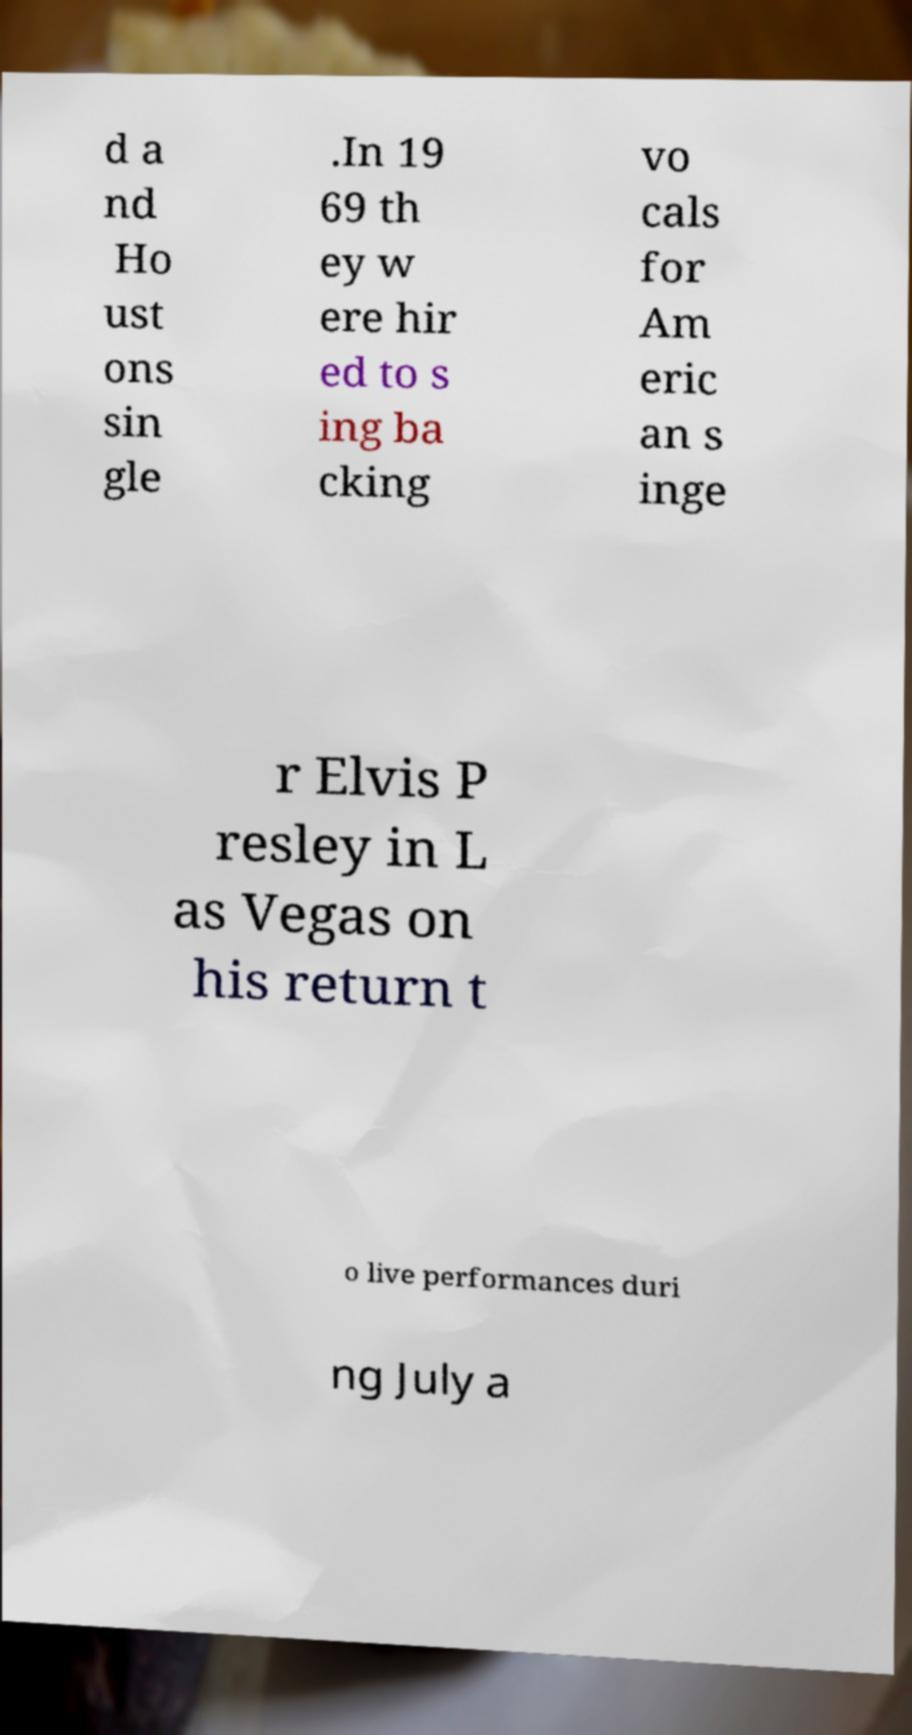Please read and relay the text visible in this image. What does it say? d a nd Ho ust ons sin gle .In 19 69 th ey w ere hir ed to s ing ba cking vo cals for Am eric an s inge r Elvis P resley in L as Vegas on his return t o live performances duri ng July a 